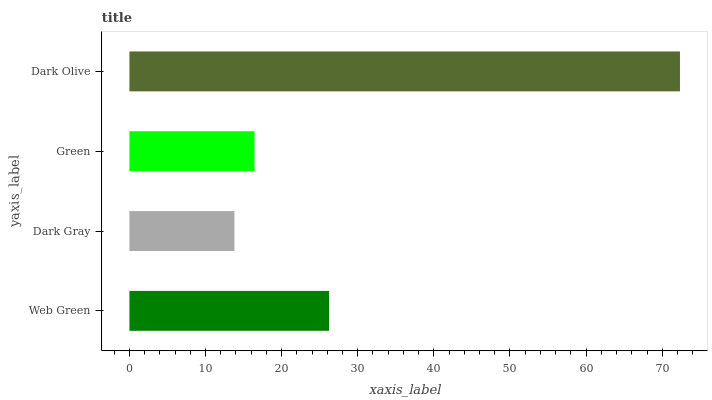Is Dark Gray the minimum?
Answer yes or no. Yes. Is Dark Olive the maximum?
Answer yes or no. Yes. Is Green the minimum?
Answer yes or no. No. Is Green the maximum?
Answer yes or no. No. Is Green greater than Dark Gray?
Answer yes or no. Yes. Is Dark Gray less than Green?
Answer yes or no. Yes. Is Dark Gray greater than Green?
Answer yes or no. No. Is Green less than Dark Gray?
Answer yes or no. No. Is Web Green the high median?
Answer yes or no. Yes. Is Green the low median?
Answer yes or no. Yes. Is Green the high median?
Answer yes or no. No. Is Web Green the low median?
Answer yes or no. No. 